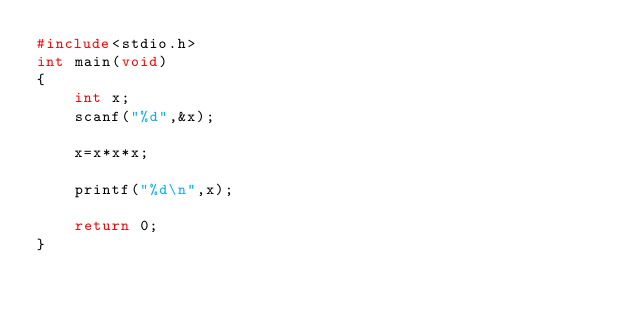<code> <loc_0><loc_0><loc_500><loc_500><_C_>#include<stdio.h>
int main(void)
{
    int x;
    scanf("%d",&x);

    x=x*x*x;

    printf("%d\n",x);

    return 0;
}</code> 